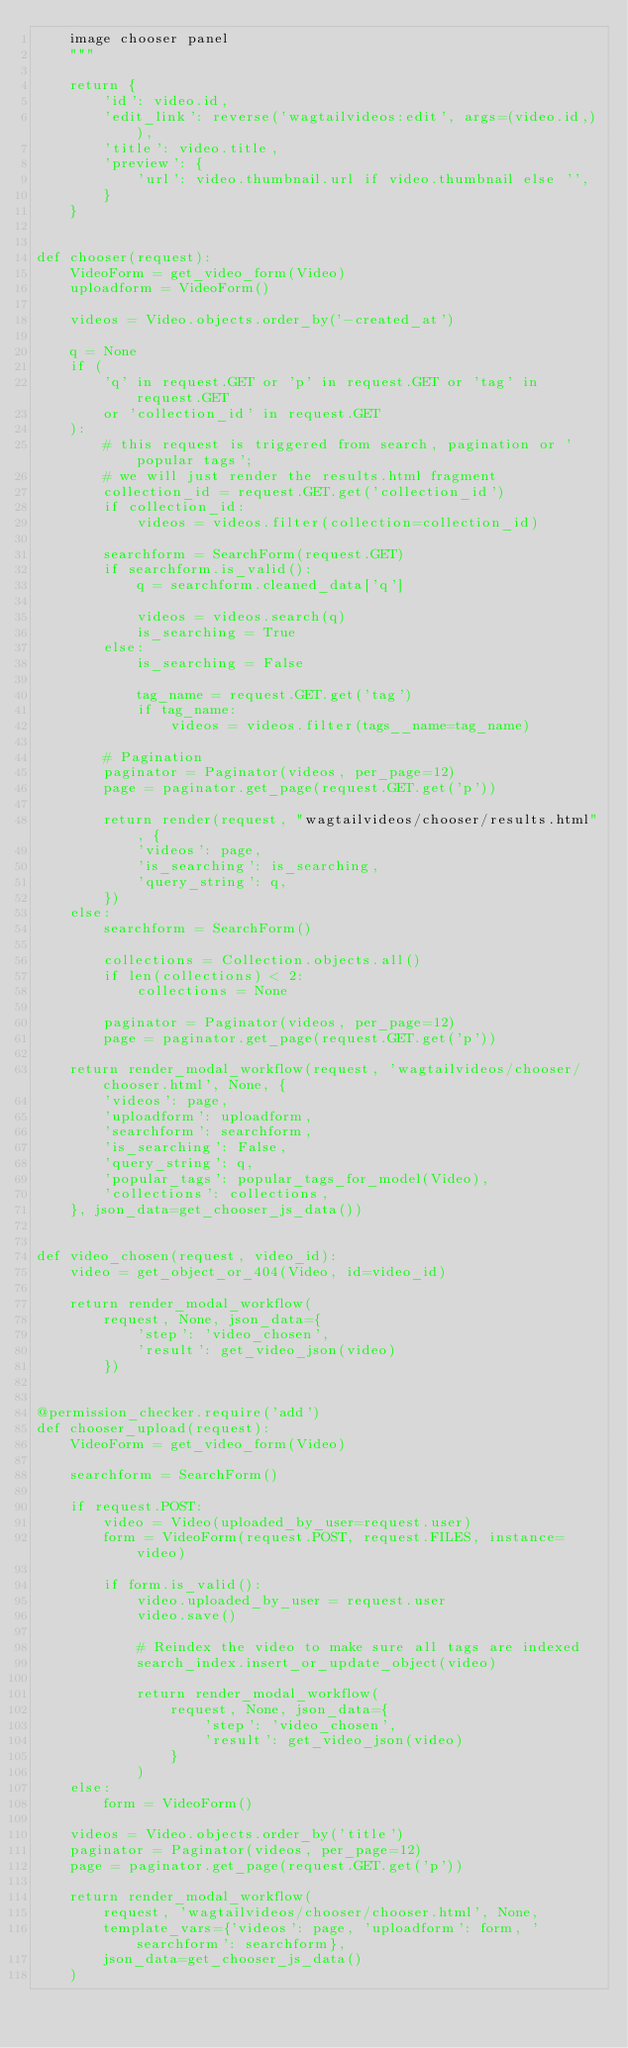Convert code to text. <code><loc_0><loc_0><loc_500><loc_500><_Python_>    image chooser panel
    """

    return {
        'id': video.id,
        'edit_link': reverse('wagtailvideos:edit', args=(video.id,)),
        'title': video.title,
        'preview': {
            'url': video.thumbnail.url if video.thumbnail else '',
        }
    }


def chooser(request):
    VideoForm = get_video_form(Video)
    uploadform = VideoForm()

    videos = Video.objects.order_by('-created_at')

    q = None
    if (
        'q' in request.GET or 'p' in request.GET or 'tag' in request.GET
        or 'collection_id' in request.GET
    ):
        # this request is triggered from search, pagination or 'popular tags';
        # we will just render the results.html fragment
        collection_id = request.GET.get('collection_id')
        if collection_id:
            videos = videos.filter(collection=collection_id)

        searchform = SearchForm(request.GET)
        if searchform.is_valid():
            q = searchform.cleaned_data['q']

            videos = videos.search(q)
            is_searching = True
        else:
            is_searching = False

            tag_name = request.GET.get('tag')
            if tag_name:
                videos = videos.filter(tags__name=tag_name)

        # Pagination
        paginator = Paginator(videos, per_page=12)
        page = paginator.get_page(request.GET.get('p'))

        return render(request, "wagtailvideos/chooser/results.html", {
            'videos': page,
            'is_searching': is_searching,
            'query_string': q,
        })
    else:
        searchform = SearchForm()

        collections = Collection.objects.all()
        if len(collections) < 2:
            collections = None

        paginator = Paginator(videos, per_page=12)
        page = paginator.get_page(request.GET.get('p'))

    return render_modal_workflow(request, 'wagtailvideos/chooser/chooser.html', None, {
        'videos': page,
        'uploadform': uploadform,
        'searchform': searchform,
        'is_searching': False,
        'query_string': q,
        'popular_tags': popular_tags_for_model(Video),
        'collections': collections,
    }, json_data=get_chooser_js_data())


def video_chosen(request, video_id):
    video = get_object_or_404(Video, id=video_id)

    return render_modal_workflow(
        request, None, json_data={
            'step': 'video_chosen',
            'result': get_video_json(video)
        })


@permission_checker.require('add')
def chooser_upload(request):
    VideoForm = get_video_form(Video)

    searchform = SearchForm()

    if request.POST:
        video = Video(uploaded_by_user=request.user)
        form = VideoForm(request.POST, request.FILES, instance=video)

        if form.is_valid():
            video.uploaded_by_user = request.user
            video.save()

            # Reindex the video to make sure all tags are indexed
            search_index.insert_or_update_object(video)

            return render_modal_workflow(
                request, None, json_data={
                    'step': 'video_chosen',
                    'result': get_video_json(video)
                }
            )
    else:
        form = VideoForm()

    videos = Video.objects.order_by('title')
    paginator = Paginator(videos, per_page=12)
    page = paginator.get_page(request.GET.get('p'))

    return render_modal_workflow(
        request, 'wagtailvideos/chooser/chooser.html', None,
        template_vars={'videos': page, 'uploadform': form, 'searchform': searchform},
        json_data=get_chooser_js_data()
    )
</code> 